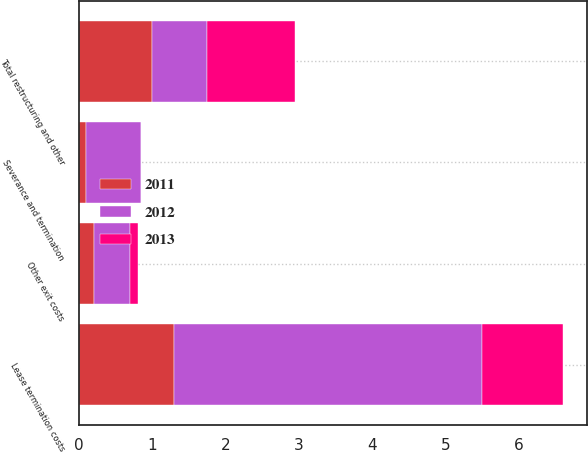Convert chart. <chart><loc_0><loc_0><loc_500><loc_500><stacked_bar_chart><ecel><fcel>Severance and termination<fcel>Lease termination costs<fcel>Other exit costs<fcel>Total restructuring and other<nl><fcel>2012<fcel>0.75<fcel>4.2<fcel>0.5<fcel>0.75<nl><fcel>2013<fcel>0<fcel>1.1<fcel>0.1<fcel>1.2<nl><fcel>2011<fcel>0.1<fcel>1.3<fcel>0.2<fcel>1<nl></chart> 